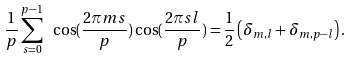<formula> <loc_0><loc_0><loc_500><loc_500>\frac { 1 } { p } \sum _ { s = 0 } ^ { p - 1 } \ \cos ( \frac { 2 \pi m s } { p } ) \cos ( \frac { 2 \pi s l } { p } ) = \frac { 1 } { 2 } \left ( \delta _ { m , l } + \delta _ { m , p - l } \right ) .</formula> 